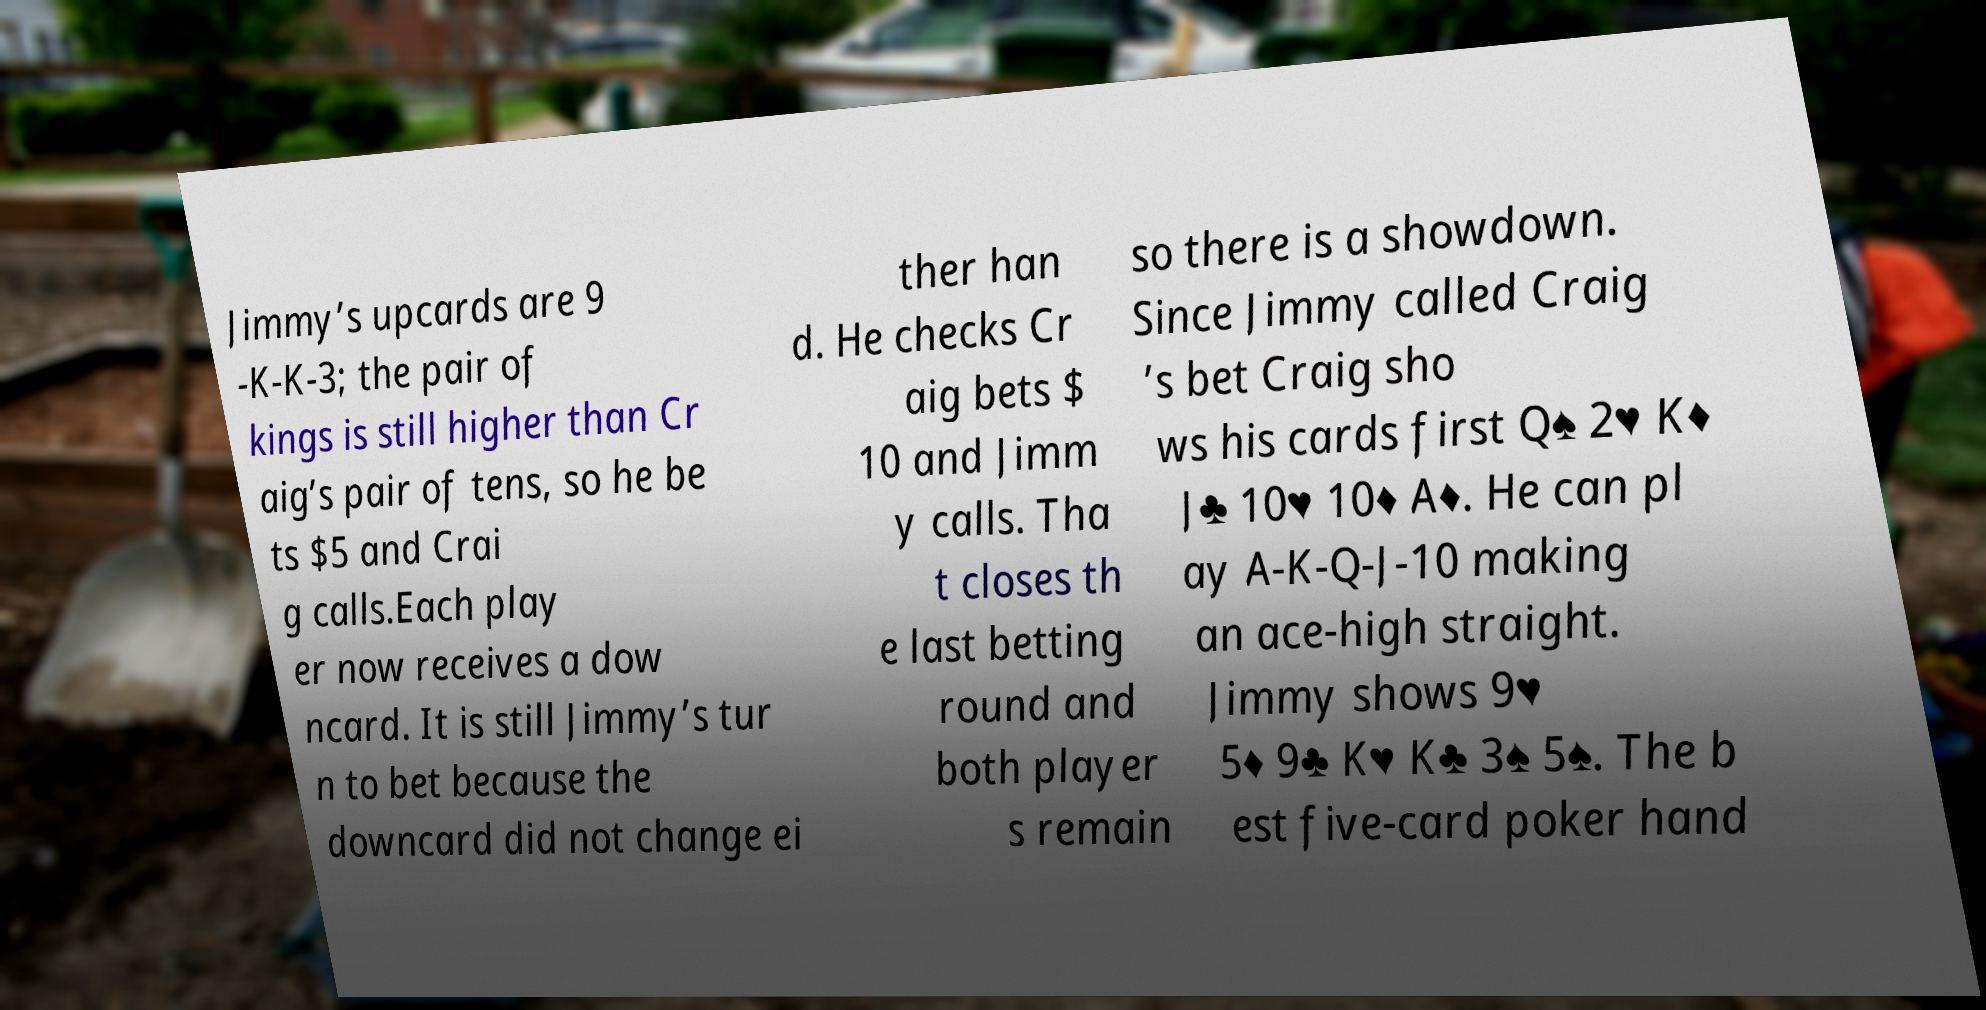What messages or text are displayed in this image? I need them in a readable, typed format. Jimmy’s upcards are 9 -K-K-3; the pair of kings is still higher than Cr aig’s pair of tens, so he be ts $5 and Crai g calls.Each play er now receives a dow ncard. It is still Jimmy’s tur n to bet because the downcard did not change ei ther han d. He checks Cr aig bets $ 10 and Jimm y calls. Tha t closes th e last betting round and both player s remain so there is a showdown. Since Jimmy called Craig ’s bet Craig sho ws his cards first Q♠ 2♥ K♦ J♣ 10♥ 10♦ A♦. He can pl ay A-K-Q-J-10 making an ace-high straight. Jimmy shows 9♥ 5♦ 9♣ K♥ K♣ 3♠ 5♠. The b est five-card poker hand 